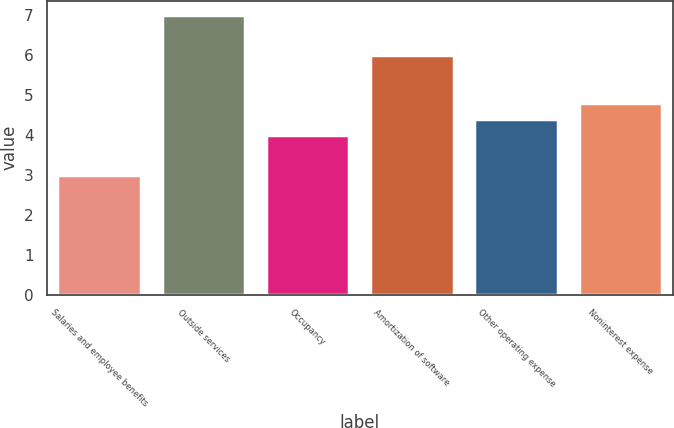<chart> <loc_0><loc_0><loc_500><loc_500><bar_chart><fcel>Salaries and employee benefits<fcel>Outside services<fcel>Occupancy<fcel>Amortization of software<fcel>Other operating expense<fcel>Noninterest expense<nl><fcel>3<fcel>7<fcel>4<fcel>6<fcel>4.4<fcel>4.8<nl></chart> 